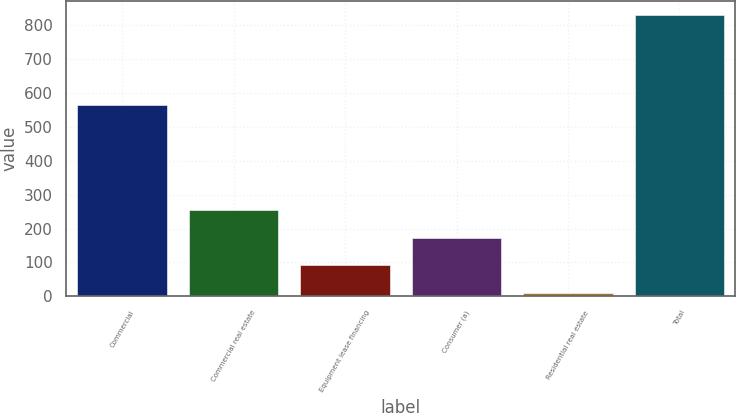Convert chart. <chart><loc_0><loc_0><loc_500><loc_500><bar_chart><fcel>Commercial<fcel>Commercial real estate<fcel>Equipment lease financing<fcel>Consumer (a)<fcel>Residential real estate<fcel>Total<nl><fcel>564<fcel>255.3<fcel>91.1<fcel>173.2<fcel>9<fcel>830<nl></chart> 